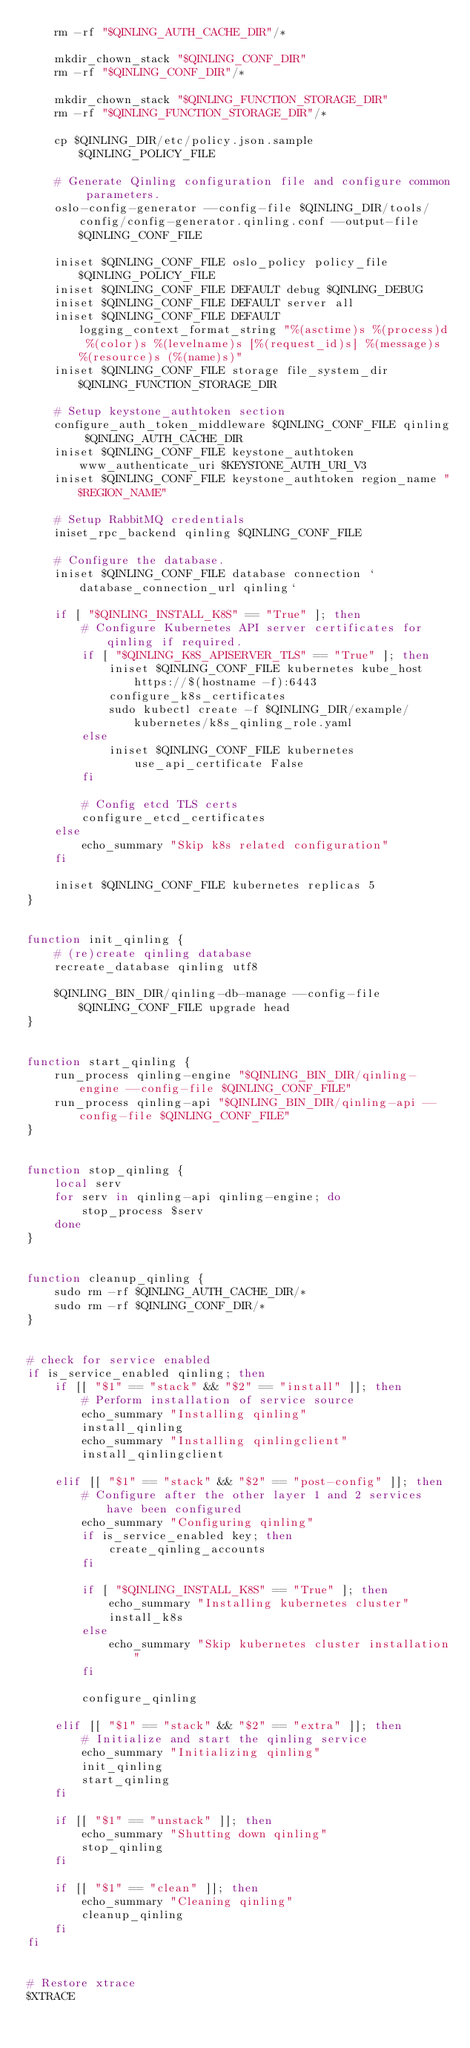<code> <loc_0><loc_0><loc_500><loc_500><_Bash_>    rm -rf "$QINLING_AUTH_CACHE_DIR"/*

    mkdir_chown_stack "$QINLING_CONF_DIR"
    rm -rf "$QINLING_CONF_DIR"/*

    mkdir_chown_stack "$QINLING_FUNCTION_STORAGE_DIR"
    rm -rf "$QINLING_FUNCTION_STORAGE_DIR"/*

    cp $QINLING_DIR/etc/policy.json.sample $QINLING_POLICY_FILE

    # Generate Qinling configuration file and configure common parameters.
    oslo-config-generator --config-file $QINLING_DIR/tools/config/config-generator.qinling.conf --output-file $QINLING_CONF_FILE

    iniset $QINLING_CONF_FILE oslo_policy policy_file $QINLING_POLICY_FILE
    iniset $QINLING_CONF_FILE DEFAULT debug $QINLING_DEBUG
    iniset $QINLING_CONF_FILE DEFAULT server all
    iniset $QINLING_CONF_FILE DEFAULT logging_context_format_string "%(asctime)s %(process)d %(color)s %(levelname)s [%(request_id)s] %(message)s %(resource)s (%(name)s)"
    iniset $QINLING_CONF_FILE storage file_system_dir $QINLING_FUNCTION_STORAGE_DIR

    # Setup keystone_authtoken section
    configure_auth_token_middleware $QINLING_CONF_FILE qinling $QINLING_AUTH_CACHE_DIR
    iniset $QINLING_CONF_FILE keystone_authtoken www_authenticate_uri $KEYSTONE_AUTH_URI_V3
    iniset $QINLING_CONF_FILE keystone_authtoken region_name "$REGION_NAME"

    # Setup RabbitMQ credentials
    iniset_rpc_backend qinling $QINLING_CONF_FILE

    # Configure the database.
    iniset $QINLING_CONF_FILE database connection `database_connection_url qinling`

    if [ "$QINLING_INSTALL_K8S" == "True" ]; then
        # Configure Kubernetes API server certificates for qinling if required.
        if [ "$QINLING_K8S_APISERVER_TLS" == "True" ]; then
            iniset $QINLING_CONF_FILE kubernetes kube_host https://$(hostname -f):6443
            configure_k8s_certificates
            sudo kubectl create -f $QINLING_DIR/example/kubernetes/k8s_qinling_role.yaml
        else
            iniset $QINLING_CONF_FILE kubernetes use_api_certificate False
        fi

        # Config etcd TLS certs
        configure_etcd_certificates
    else
        echo_summary "Skip k8s related configuration"
    fi

    iniset $QINLING_CONF_FILE kubernetes replicas 5
}


function init_qinling {
    # (re)create qinling database
    recreate_database qinling utf8

    $QINLING_BIN_DIR/qinling-db-manage --config-file $QINLING_CONF_FILE upgrade head
}


function start_qinling {
    run_process qinling-engine "$QINLING_BIN_DIR/qinling-engine --config-file $QINLING_CONF_FILE"
    run_process qinling-api "$QINLING_BIN_DIR/qinling-api --config-file $QINLING_CONF_FILE"
}


function stop_qinling {
    local serv
    for serv in qinling-api qinling-engine; do
        stop_process $serv
    done
}


function cleanup_qinling {
    sudo rm -rf $QINLING_AUTH_CACHE_DIR/*
    sudo rm -rf $QINLING_CONF_DIR/*
}


# check for service enabled
if is_service_enabled qinling; then
    if [[ "$1" == "stack" && "$2" == "install" ]]; then
        # Perform installation of service source
        echo_summary "Installing qinling"
        install_qinling
        echo_summary "Installing qinlingclient"
        install_qinlingclient

    elif [[ "$1" == "stack" && "$2" == "post-config" ]]; then
        # Configure after the other layer 1 and 2 services have been configured
        echo_summary "Configuring qinling"
        if is_service_enabled key; then
            create_qinling_accounts
        fi

        if [ "$QINLING_INSTALL_K8S" == "True" ]; then
            echo_summary "Installing kubernetes cluster"
            install_k8s
        else
            echo_summary "Skip kubernetes cluster installation"
        fi

        configure_qinling

    elif [[ "$1" == "stack" && "$2" == "extra" ]]; then
        # Initialize and start the qinling service
        echo_summary "Initializing qinling"
        init_qinling
        start_qinling
    fi

    if [[ "$1" == "unstack" ]]; then
        echo_summary "Shutting down qinling"
        stop_qinling
    fi

    if [[ "$1" == "clean" ]]; then
        echo_summary "Cleaning qinling"
        cleanup_qinling
    fi
fi


# Restore xtrace
$XTRACE
</code> 